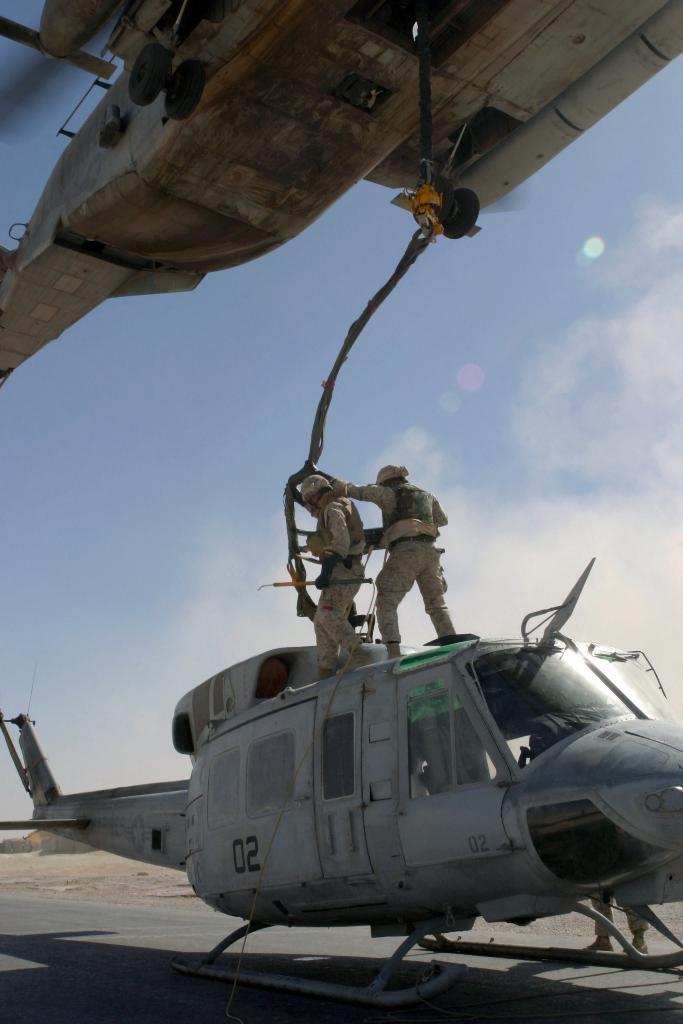<image>
Summarize the visual content of the image. two military helicopters with the numbers 02 on the bottom one 